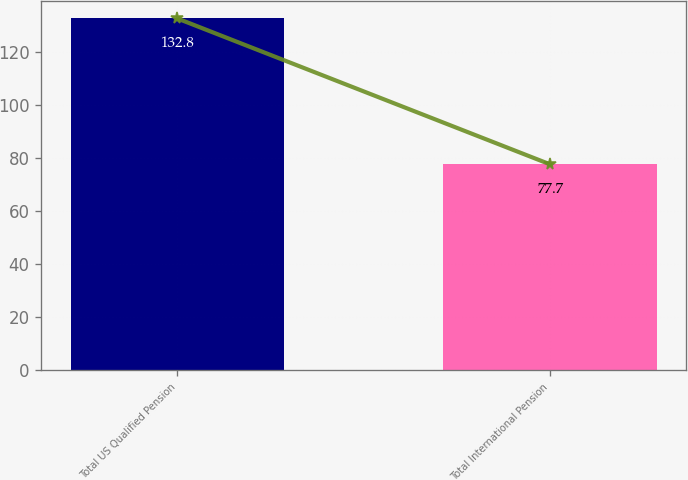<chart> <loc_0><loc_0><loc_500><loc_500><bar_chart><fcel>Total US Qualified Pension<fcel>Total International Pension<nl><fcel>132.8<fcel>77.7<nl></chart> 